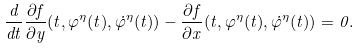<formula> <loc_0><loc_0><loc_500><loc_500>\frac { d } { d t } \frac { \partial f } { \partial y } ( t , \varphi ^ { \eta } ( t ) , \dot { \varphi } ^ { \eta } ( t ) ) - \frac { \partial f } { \partial x } ( t , \varphi ^ { \eta } ( t ) , \dot { \varphi } ^ { \eta } ( t ) ) = 0 .</formula> 